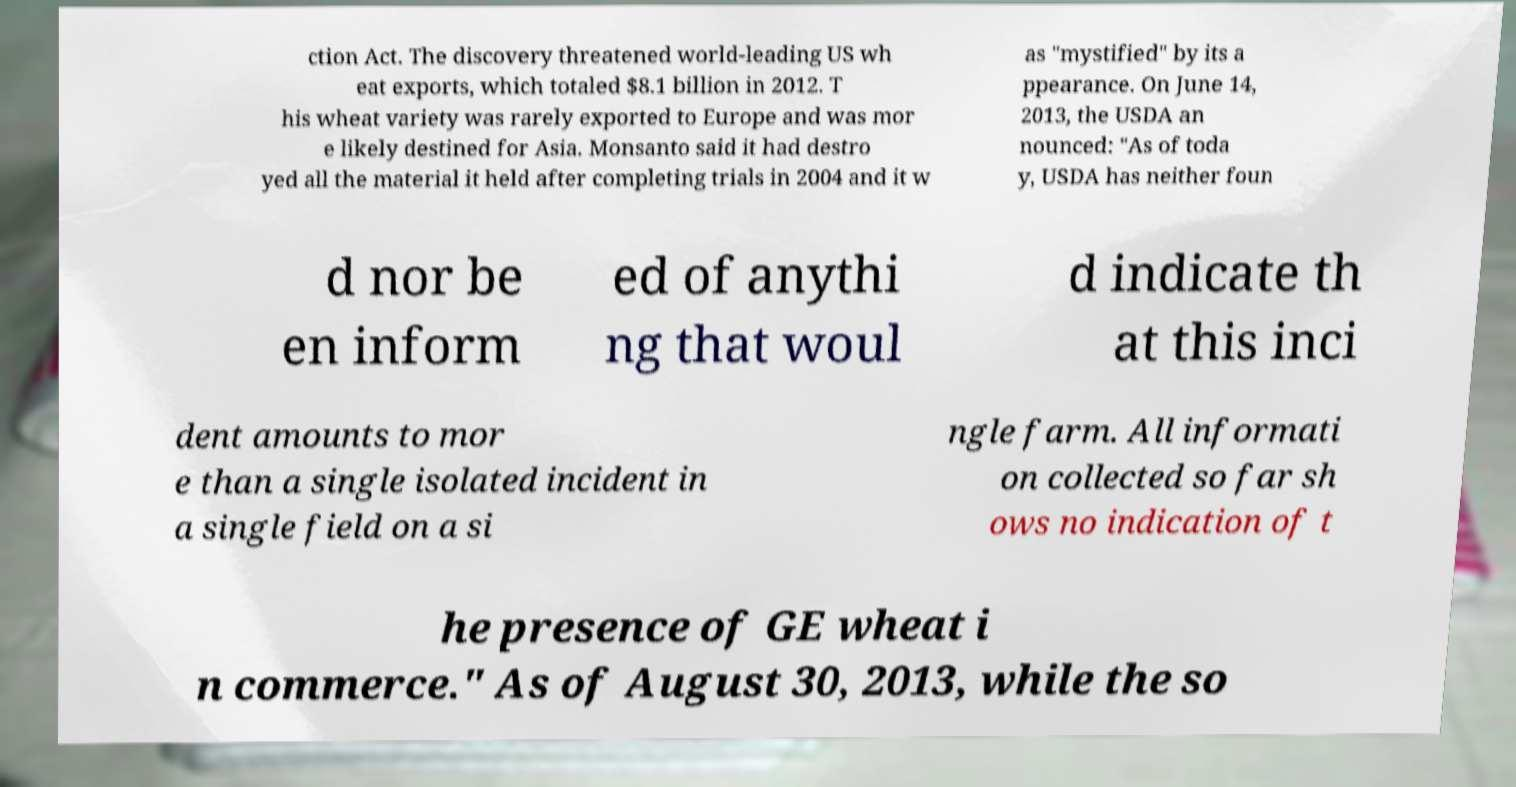Can you read and provide the text displayed in the image?This photo seems to have some interesting text. Can you extract and type it out for me? ction Act. The discovery threatened world-leading US wh eat exports, which totaled $8.1 billion in 2012. T his wheat variety was rarely exported to Europe and was mor e likely destined for Asia. Monsanto said it had destro yed all the material it held after completing trials in 2004 and it w as "mystified" by its a ppearance. On June 14, 2013, the USDA an nounced: "As of toda y, USDA has neither foun d nor be en inform ed of anythi ng that woul d indicate th at this inci dent amounts to mor e than a single isolated incident in a single field on a si ngle farm. All informati on collected so far sh ows no indication of t he presence of GE wheat i n commerce." As of August 30, 2013, while the so 